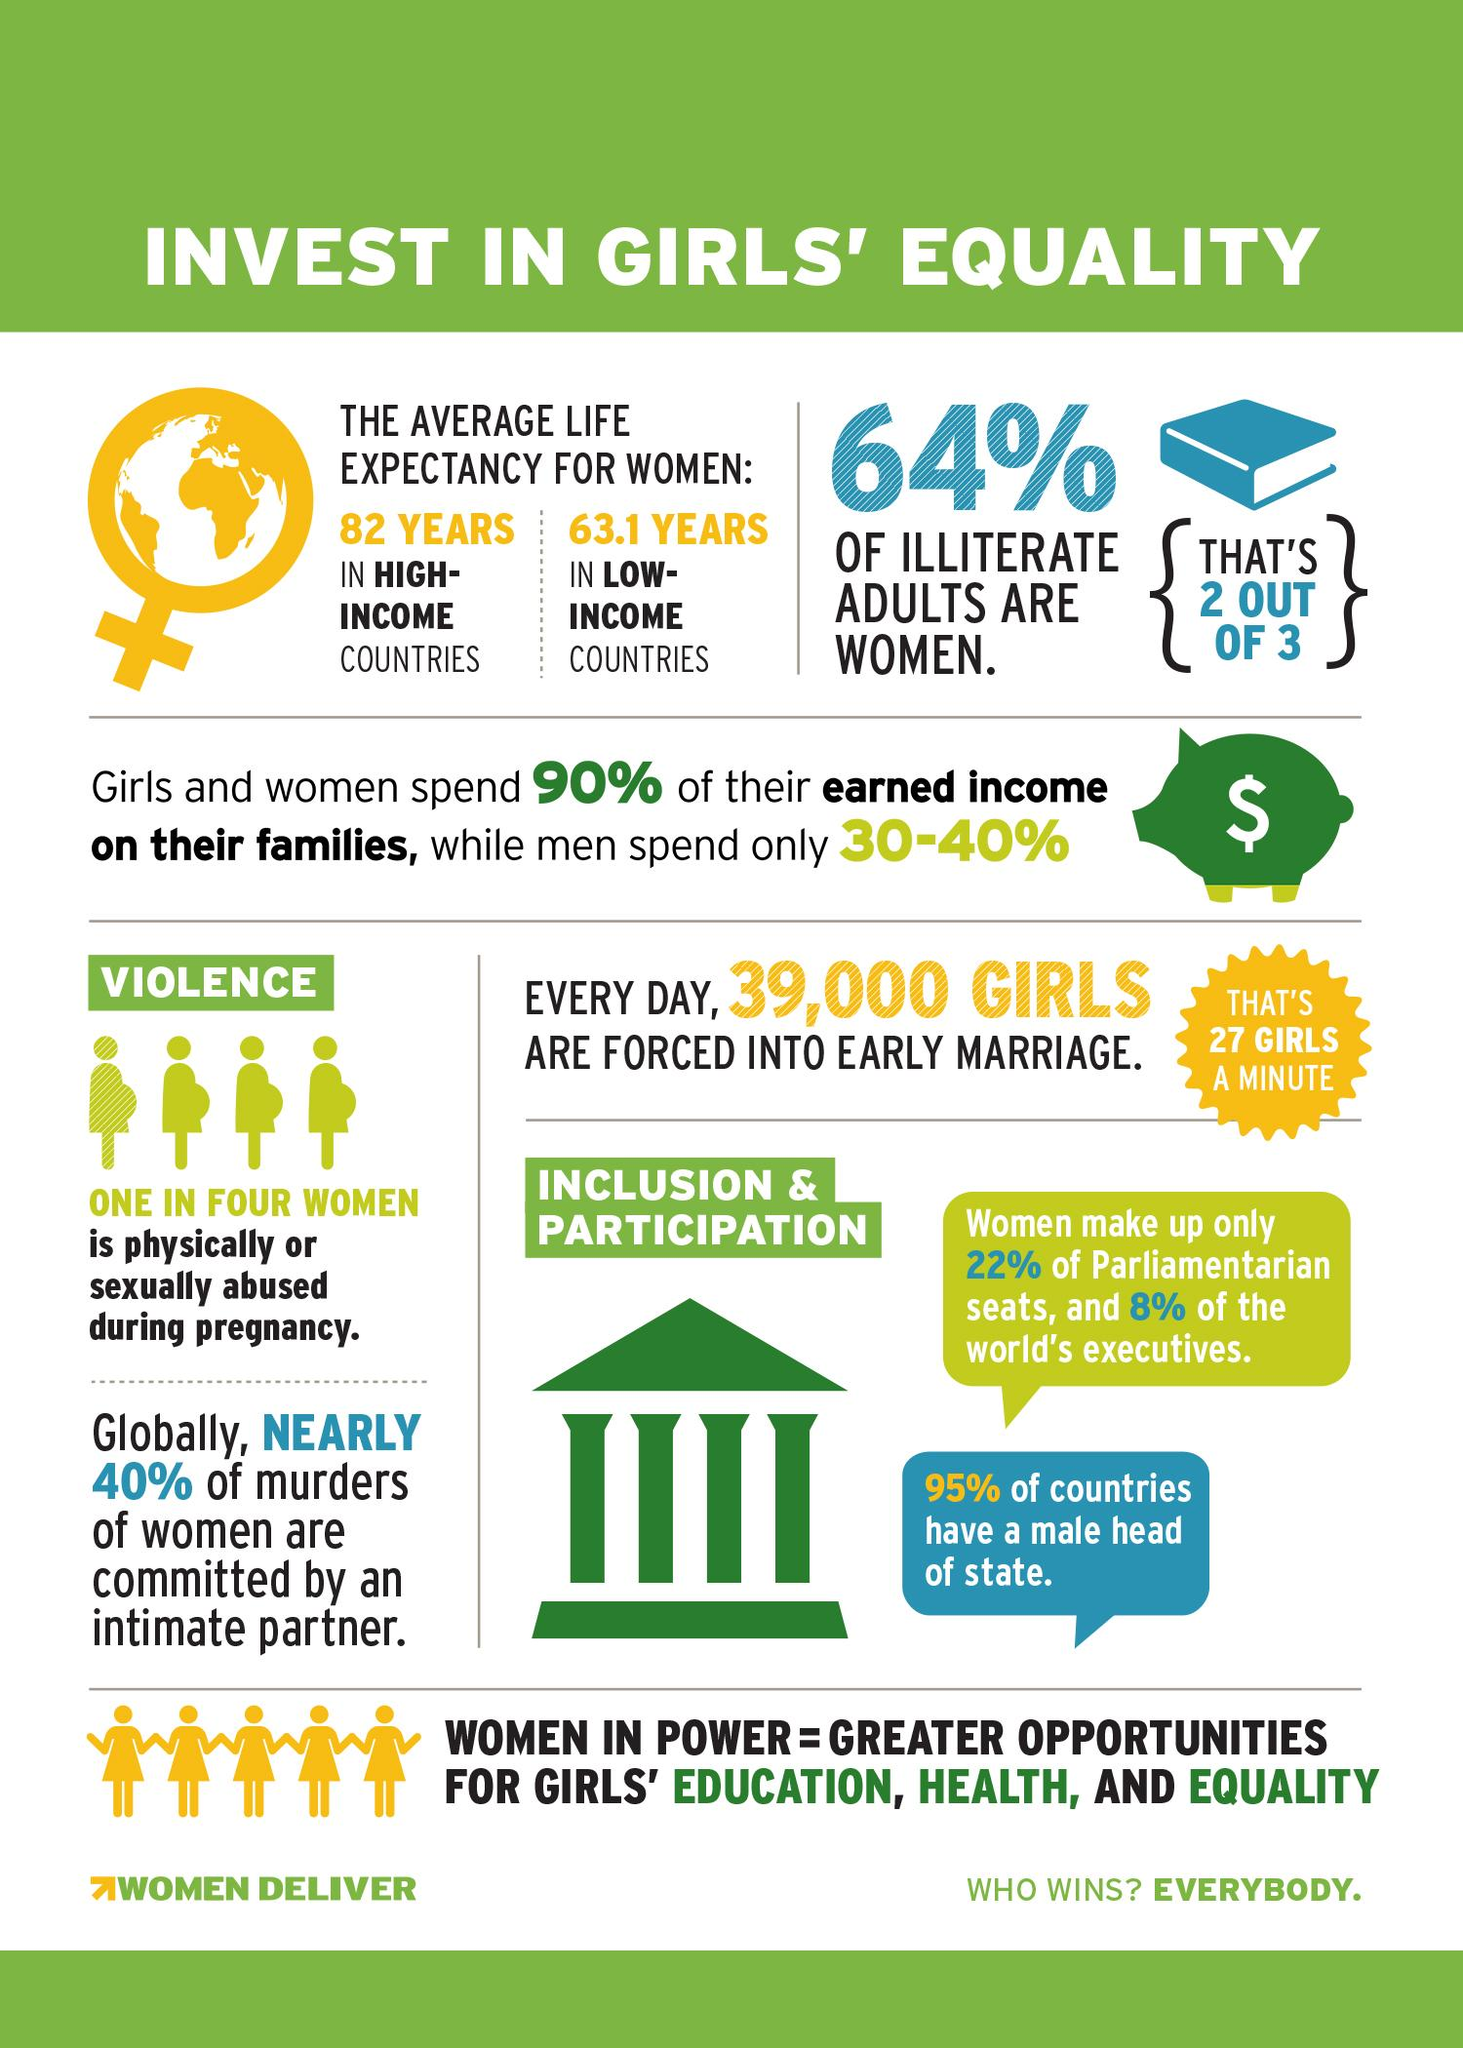Identify some key points in this picture. Only 8% of the world's executives are women, according to recent data. 